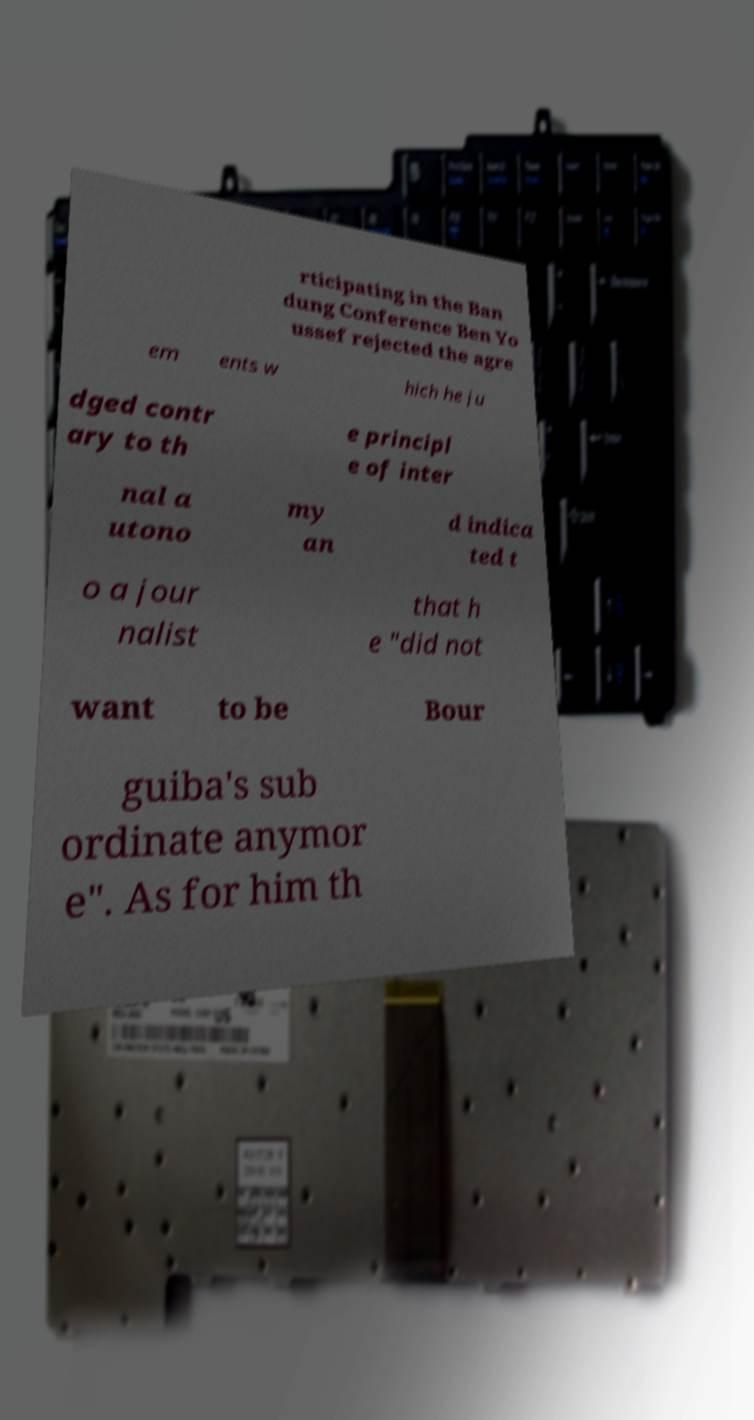Could you assist in decoding the text presented in this image and type it out clearly? rticipating in the Ban dung Conference Ben Yo ussef rejected the agre em ents w hich he ju dged contr ary to th e principl e of inter nal a utono my an d indica ted t o a jour nalist that h e "did not want to be Bour guiba's sub ordinate anymor e". As for him th 